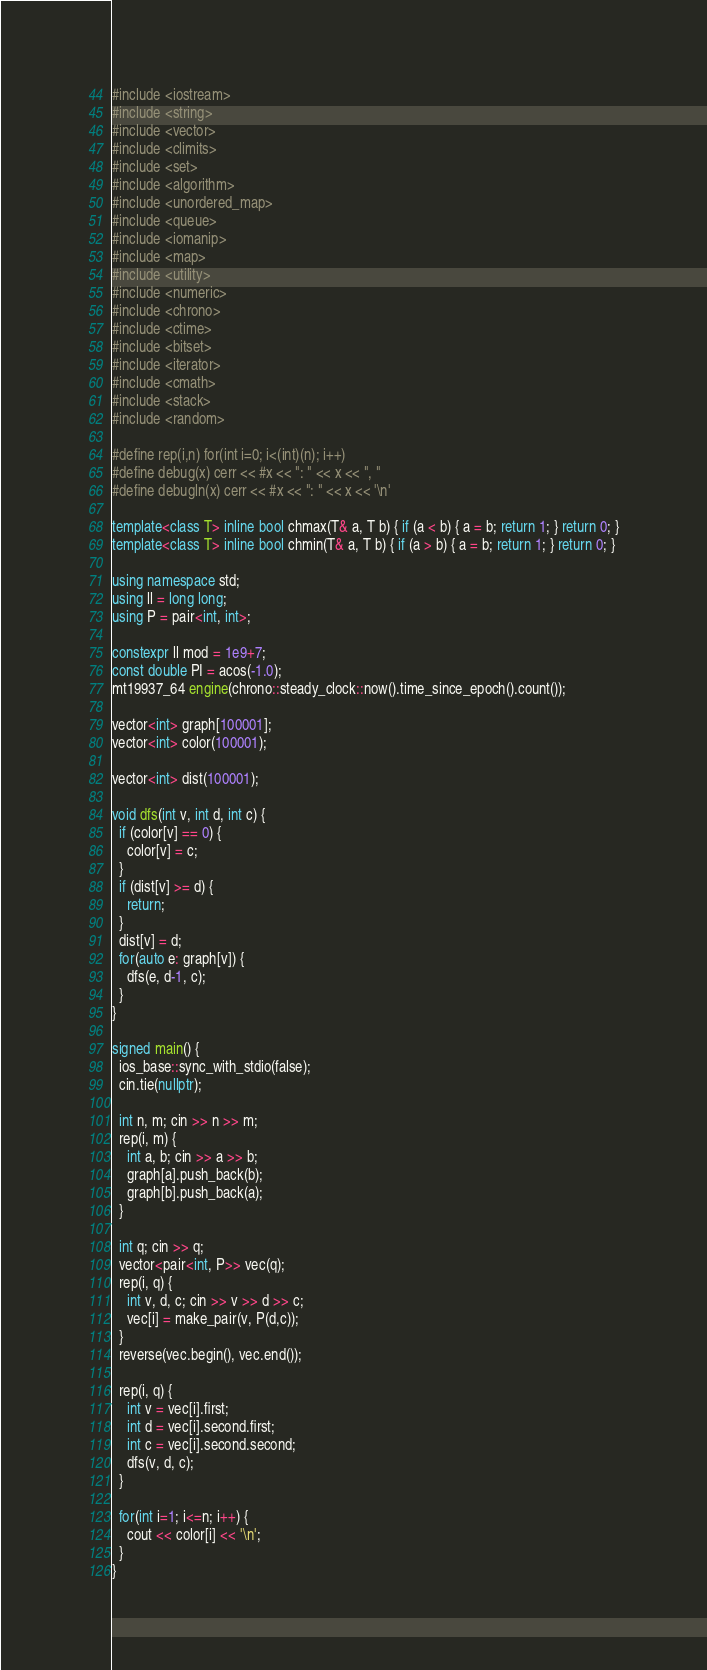<code> <loc_0><loc_0><loc_500><loc_500><_C++_>#include <iostream>
#include <string>
#include <vector>
#include <climits>
#include <set>
#include <algorithm>
#include <unordered_map>
#include <queue>
#include <iomanip>
#include <map>
#include <utility>
#include <numeric>
#include <chrono>
#include <ctime>
#include <bitset>
#include <iterator>
#include <cmath>
#include <stack>
#include <random>

#define rep(i,n) for(int i=0; i<(int)(n); i++)
#define debug(x) cerr << #x << ": " << x << ", "
#define debugln(x) cerr << #x << ": " << x << '\n'

template<class T> inline bool chmax(T& a, T b) { if (a < b) { a = b; return 1; } return 0; }
template<class T> inline bool chmin(T& a, T b) { if (a > b) { a = b; return 1; } return 0; }

using namespace std;
using ll = long long;
using P = pair<int, int>;

constexpr ll mod = 1e9+7;
const double PI = acos(-1.0);
mt19937_64 engine(chrono::steady_clock::now().time_since_epoch().count());

vector<int> graph[100001];
vector<int> color(100001);

vector<int> dist(100001);

void dfs(int v, int d, int c) {
  if (color[v] == 0) {
    color[v] = c;
  }
  if (dist[v] >= d) {
    return;
  }
  dist[v] = d;
  for(auto e: graph[v]) {
    dfs(e, d-1, c);
  }
}

signed main() {
  ios_base::sync_with_stdio(false);
  cin.tie(nullptr);

  int n, m; cin >> n >> m;
  rep(i, m) {
    int a, b; cin >> a >> b;
    graph[a].push_back(b);
    graph[b].push_back(a);
  }

  int q; cin >> q;
  vector<pair<int, P>> vec(q);
  rep(i, q) {
    int v, d, c; cin >> v >> d >> c;
    vec[i] = make_pair(v, P(d,c));
  }
  reverse(vec.begin(), vec.end());  

  rep(i, q) {
    int v = vec[i].first;
    int d = vec[i].second.first;
    int c = vec[i].second.second;
    dfs(v, d, c);
  }

  for(int i=1; i<=n; i++) {
    cout << color[i] << '\n';
  }
}
</code> 